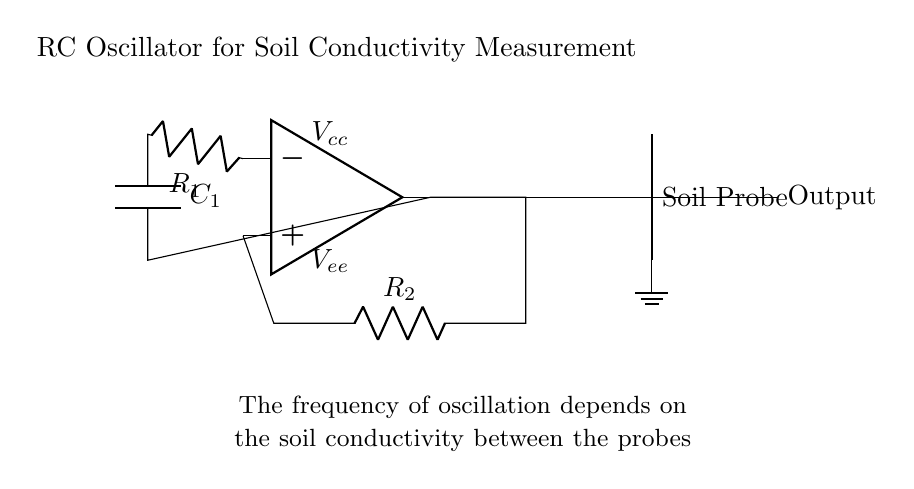What is the main component of this circuit? The main component is the operational amplifier, which is designed to amplify the input voltage and generate oscillations in conjunction with the resistors and capacitors.
Answer: operational amplifier What does the soil probe measure? The soil probe measures the soil conductivity, which is the ability of the soil to conduct electric current, affected by its contamination level.
Answer: soil conductivity What are the resistance values in this circuit? The resistor values are denoted as R1 and R2, but the circuit does not specify numerical values. They work together in setting the frequency of oscillation based on soil conductivity.
Answer: R1 and R2 How does the frequency of oscillation relate to soil conductivity? The frequency of oscillation is inversely proportional to the conductivity; higher soil conductivity leads to lower resistance, which in turn increases the frequency of oscillation produced by the RC oscillator.
Answer: inversely proportional What role does the capacitor play in this oscillator circuit? The capacitor, C1, stores charge and together with resistors, it determines the time constant of the circuit, impacting the frequency of oscillation.
Answer: stores charge Which element provides the ground reference in this circuit? The ground reference is provided by the node that connects to the soil probe's lower point, indicated by the ground symbol in the diagram.
Answer: ground symbol What effect does increasing R1 have on the oscillator? Increasing R1 would typically increase the time constant of the circuit, thereby decreasing the frequency of oscillation since it would take longer for the capacitor to charge and discharge.
Answer: decreases frequency 